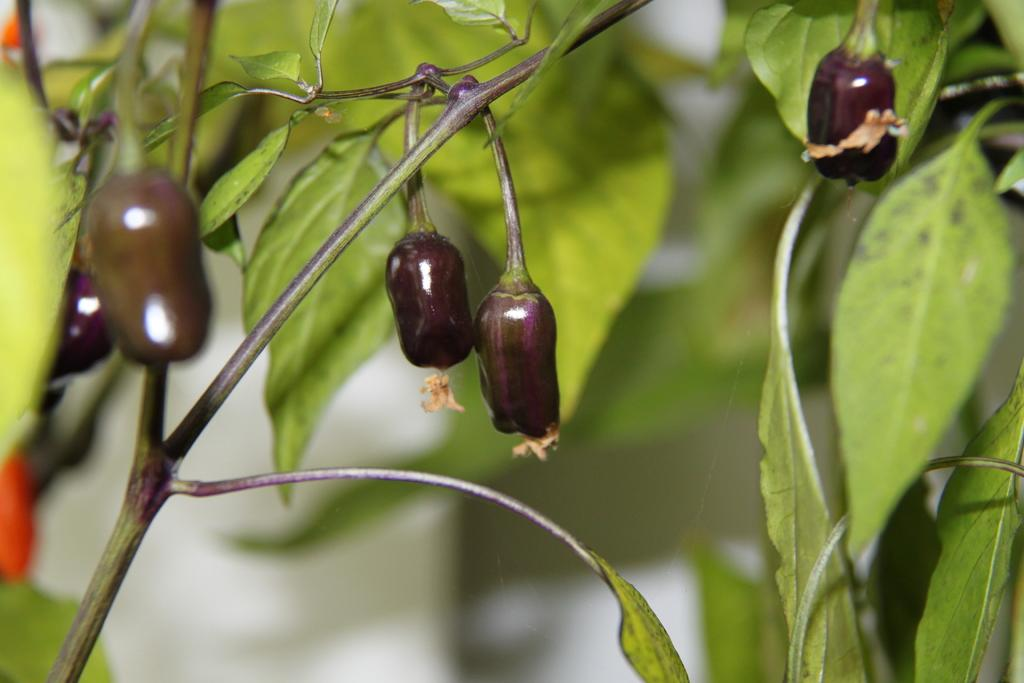What type of plant is in the image? There is a brinjal plant in the image. What type of news can be heard coming from the brinjal plant in the image? There is no indication in the image that the brinjal plant is producing or transmitting any news, as plants do not have the ability to generate or broadcast news. 